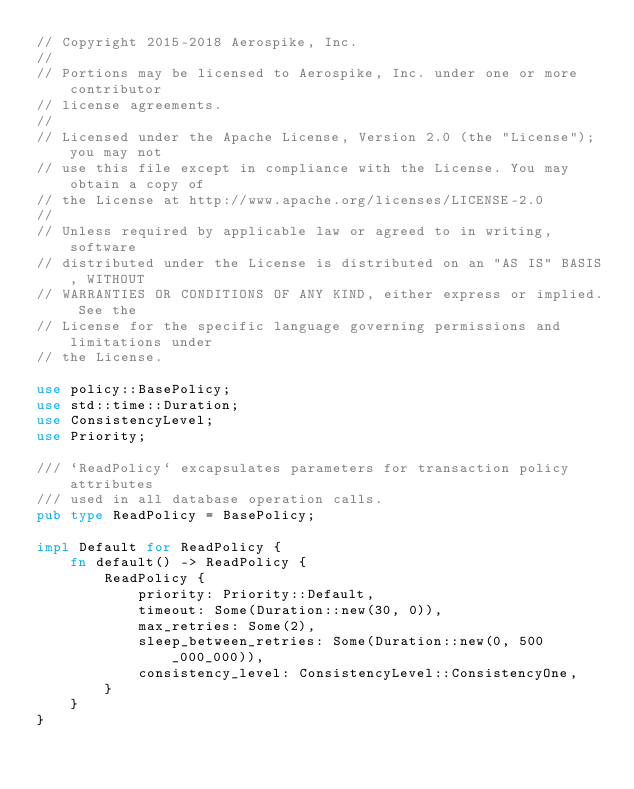<code> <loc_0><loc_0><loc_500><loc_500><_Rust_>// Copyright 2015-2018 Aerospike, Inc.
//
// Portions may be licensed to Aerospike, Inc. under one or more contributor
// license agreements.
//
// Licensed under the Apache License, Version 2.0 (the "License"); you may not
// use this file except in compliance with the License. You may obtain a copy of
// the License at http://www.apache.org/licenses/LICENSE-2.0
//
// Unless required by applicable law or agreed to in writing, software
// distributed under the License is distributed on an "AS IS" BASIS, WITHOUT
// WARRANTIES OR CONDITIONS OF ANY KIND, either express or implied. See the
// License for the specific language governing permissions and limitations under
// the License.

use policy::BasePolicy;
use std::time::Duration;
use ConsistencyLevel;
use Priority;

/// `ReadPolicy` excapsulates parameters for transaction policy attributes
/// used in all database operation calls.
pub type ReadPolicy = BasePolicy;

impl Default for ReadPolicy {
    fn default() -> ReadPolicy {
        ReadPolicy {
            priority: Priority::Default,
            timeout: Some(Duration::new(30, 0)),
            max_retries: Some(2),
            sleep_between_retries: Some(Duration::new(0, 500_000_000)),
            consistency_level: ConsistencyLevel::ConsistencyOne,
        }
    }
}
</code> 